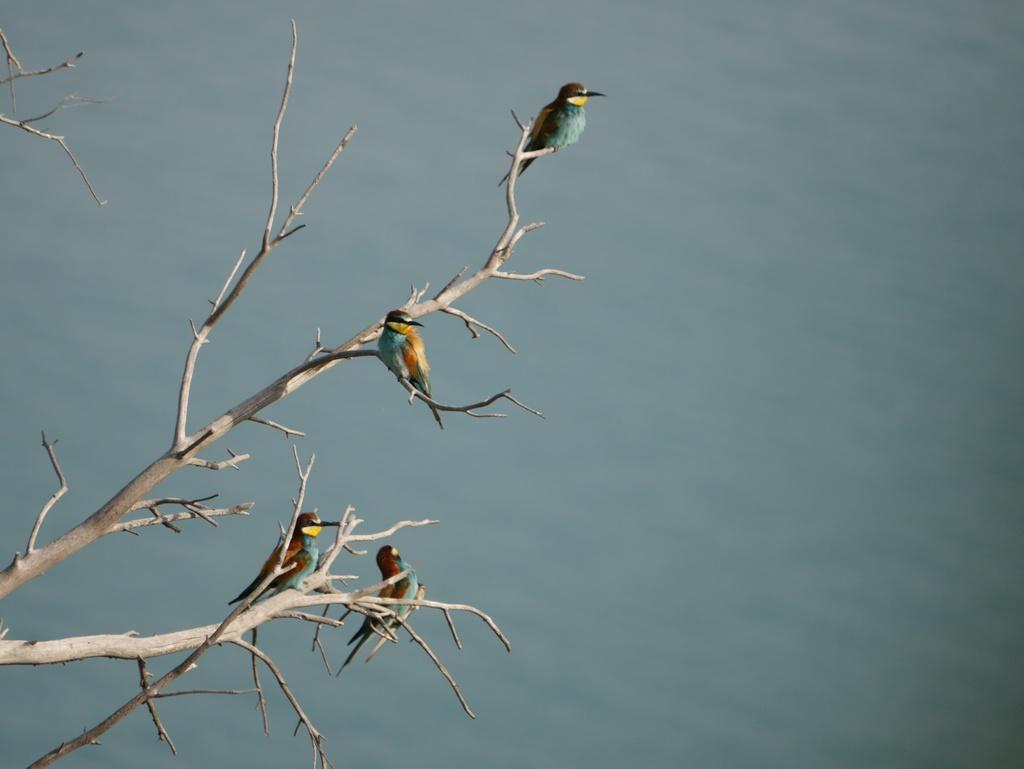How many birds are present in the image? There are four birds in the image. What are the birds doing in the image? The birds are standing on a tree branch. What can be seen in the background of the image? The background of the image might be water or sky. Are the birds sleeping while standing on the tree branch in the image? There is no indication in the image that the birds are sleeping; they are standing on the tree branch. Who is the representative of the birds in the image? There is no specific representative for the birds in the image, as they are not depicted as having any human-like qualities or roles. 